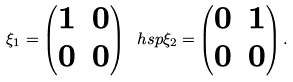<formula> <loc_0><loc_0><loc_500><loc_500>\xi _ { 1 } = \begin{pmatrix} 1 & 0 \\ 0 & 0 \end{pmatrix} \ h s p \xi _ { 2 } = \begin{pmatrix} 0 & 1 \\ 0 & 0 \end{pmatrix} .</formula> 